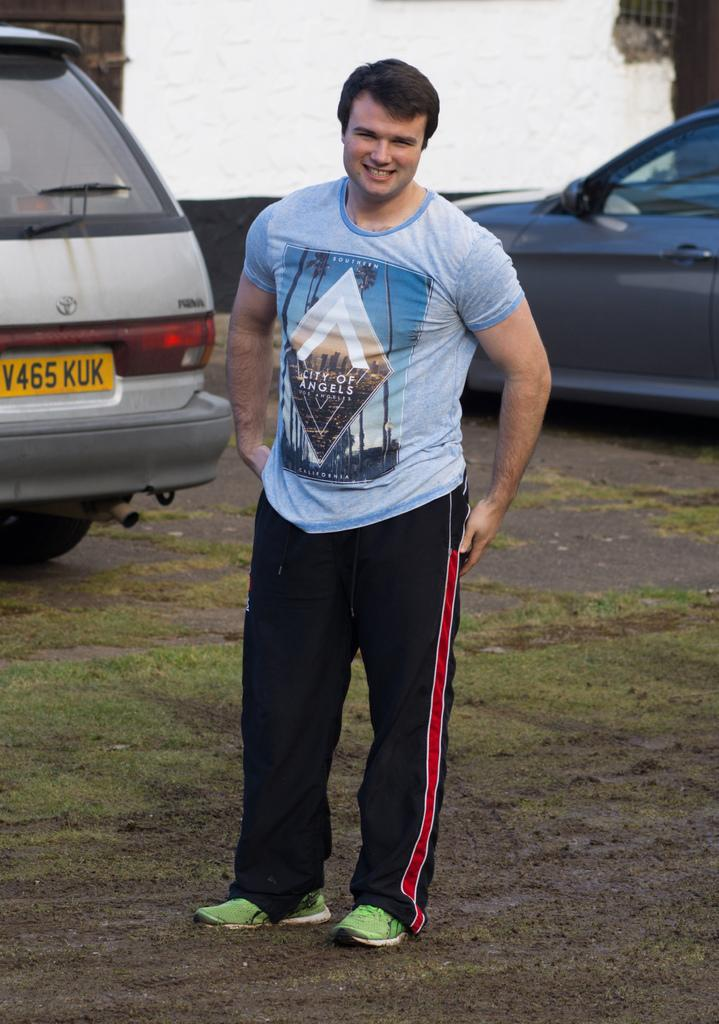What is the person in the image wearing on their upper body? The person is wearing a t-shirt. What color are the pants the person is wearing? The person is wearing black pants. What can be seen in the background of the image? There are vehicles and a white color wall in the background of the image. What type of vegetation is present on the ground in the image? There are grasses on the ground in the image. How many dolls are sitting on the leaf in the image? There are no dolls or leaves present in the image. 